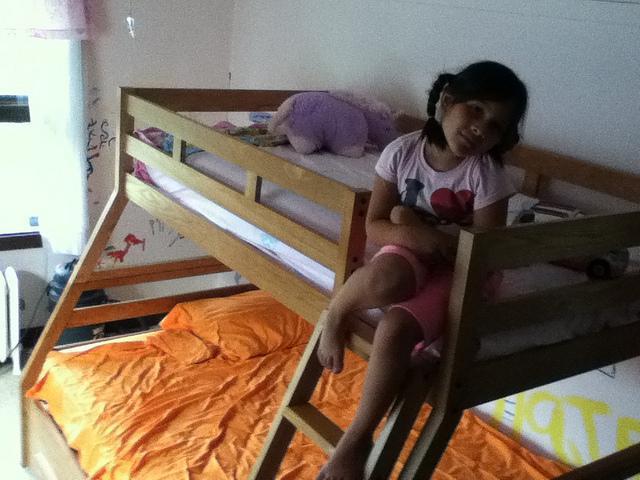How many beds are there?
Give a very brief answer. 2. 